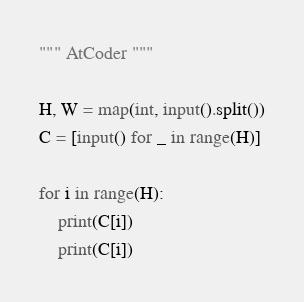<code> <loc_0><loc_0><loc_500><loc_500><_Python_>""" AtCoder """

H, W = map(int, input().split())
C = [input() for _ in range(H)]

for i in range(H):
    print(C[i])
    print(C[i])
</code> 